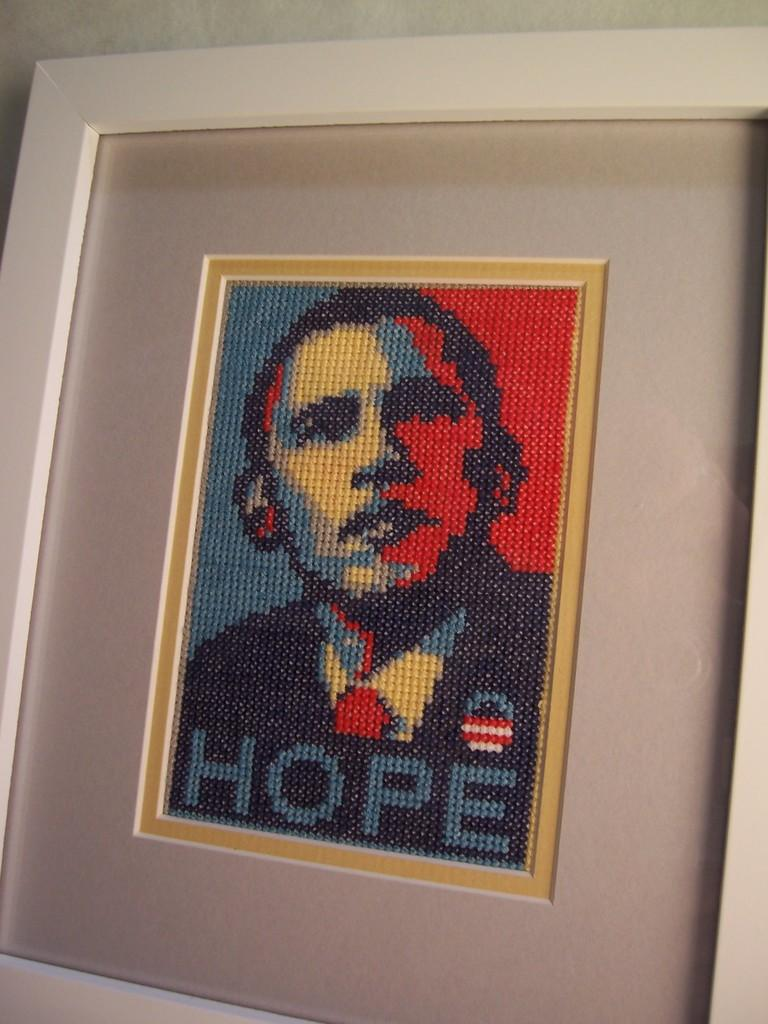What object is present in the image that typically holds a picture or artwork? There is a photo frame in the image. What is displayed within the photo frame? The photo frame contains an art piece. How does the art piece in the photo frame turn around in the image? The art piece in the photo frame does not turn around in the image; it is stationary within the frame. 